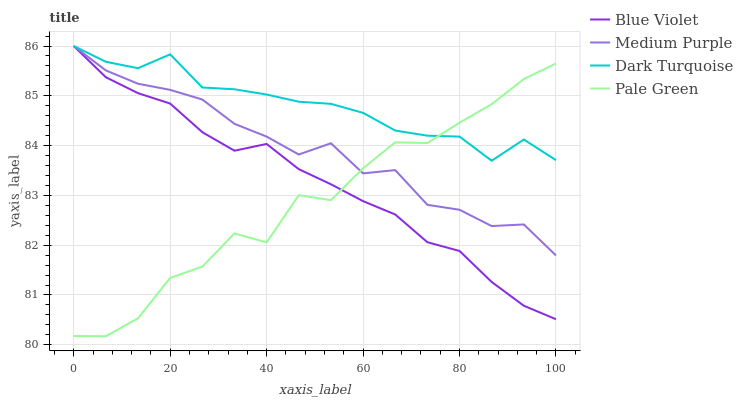Does Pale Green have the minimum area under the curve?
Answer yes or no. Yes. Does Dark Turquoise have the maximum area under the curve?
Answer yes or no. Yes. Does Dark Turquoise have the minimum area under the curve?
Answer yes or no. No. Does Pale Green have the maximum area under the curve?
Answer yes or no. No. Is Blue Violet the smoothest?
Answer yes or no. Yes. Is Pale Green the roughest?
Answer yes or no. Yes. Is Dark Turquoise the smoothest?
Answer yes or no. No. Is Dark Turquoise the roughest?
Answer yes or no. No. Does Dark Turquoise have the lowest value?
Answer yes or no. No. Does Pale Green have the highest value?
Answer yes or no. No. 